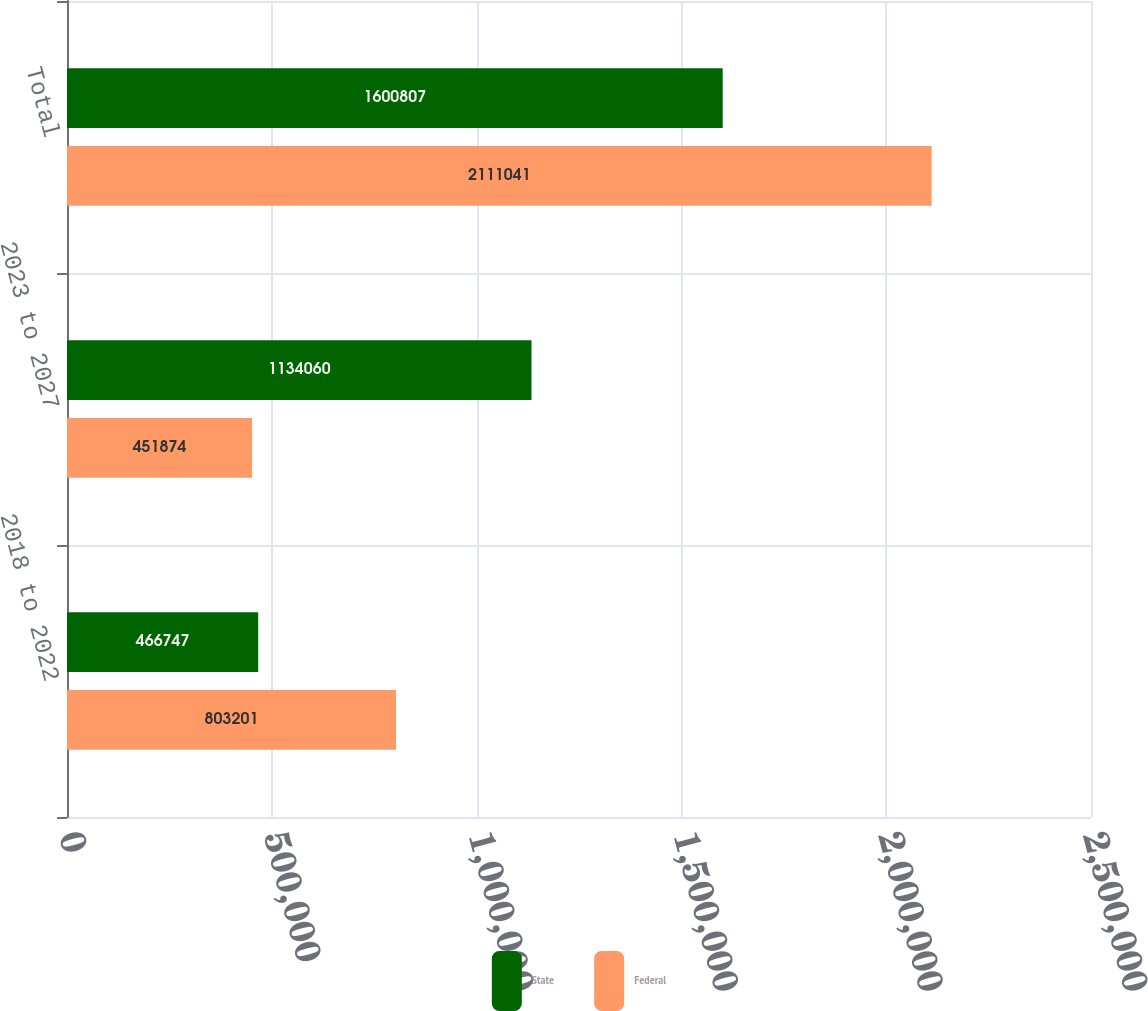<chart> <loc_0><loc_0><loc_500><loc_500><stacked_bar_chart><ecel><fcel>2018 to 2022<fcel>2023 to 2027<fcel>Total<nl><fcel>State<fcel>466747<fcel>1.13406e+06<fcel>1.60081e+06<nl><fcel>Federal<fcel>803201<fcel>451874<fcel>2.11104e+06<nl></chart> 